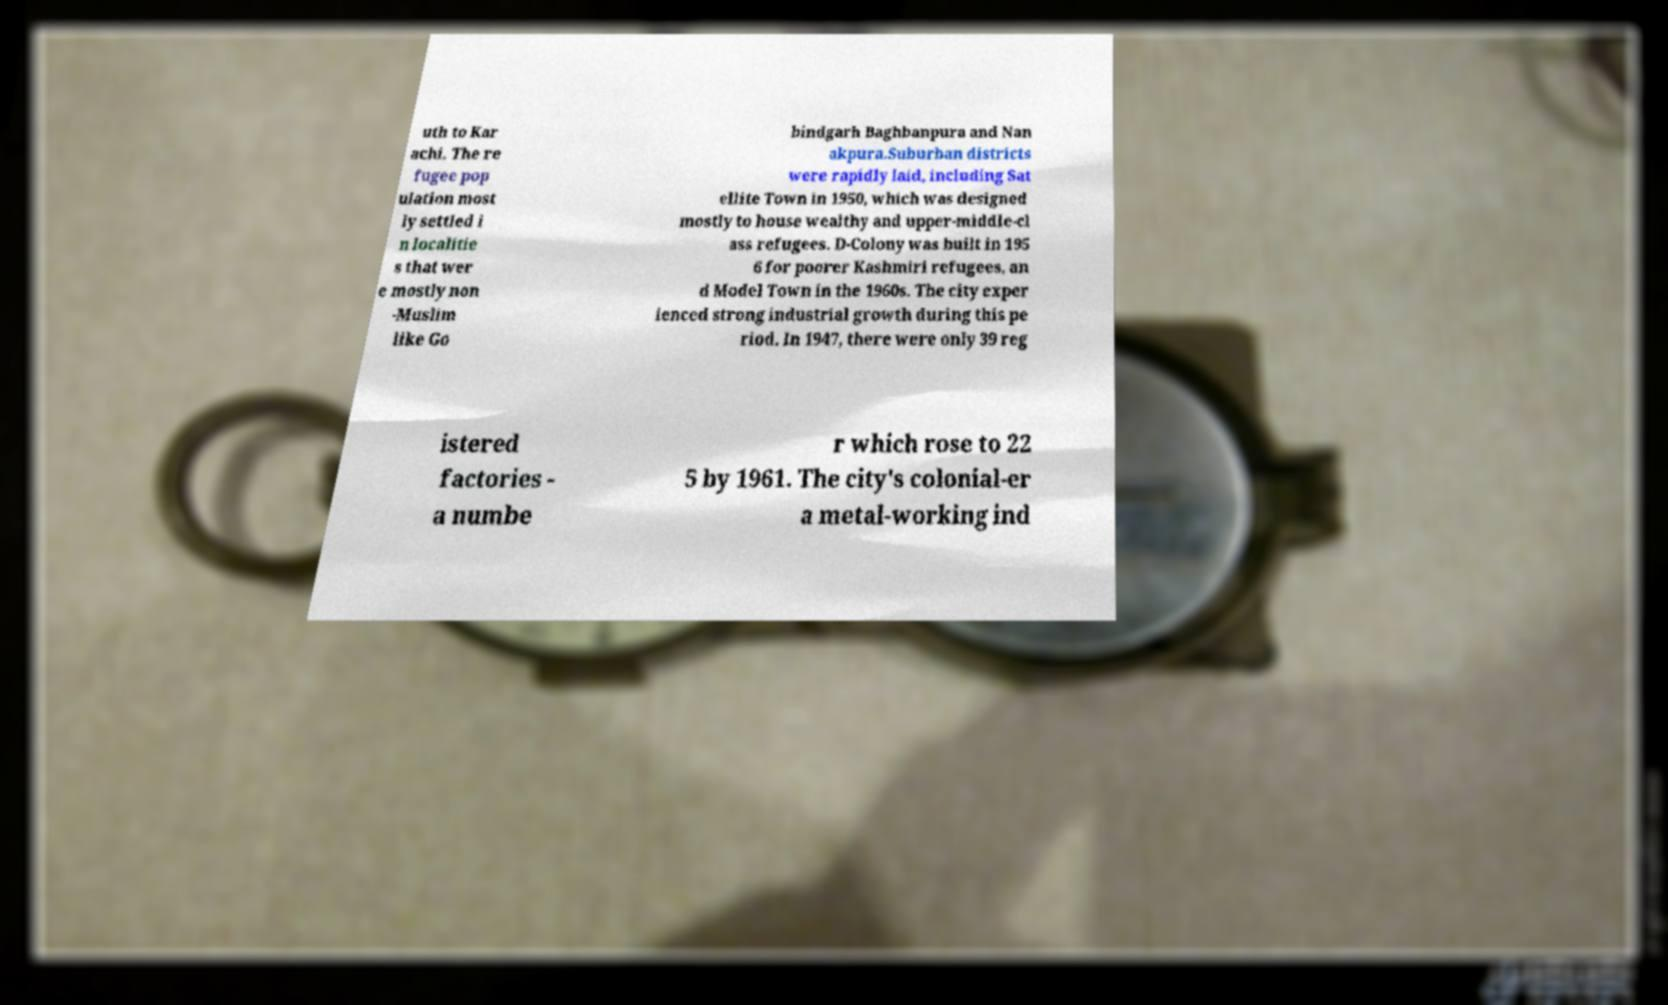What messages or text are displayed in this image? I need them in a readable, typed format. uth to Kar achi. The re fugee pop ulation most ly settled i n localitie s that wer e mostly non -Muslim like Go bindgarh Baghbanpura and Nan akpura.Suburban districts were rapidly laid, including Sat ellite Town in 1950, which was designed mostly to house wealthy and upper-middle-cl ass refugees. D-Colony was built in 195 6 for poorer Kashmiri refugees, an d Model Town in the 1960s. The city exper ienced strong industrial growth during this pe riod. In 1947, there were only 39 reg istered factories - a numbe r which rose to 22 5 by 1961. The city's colonial-er a metal-working ind 